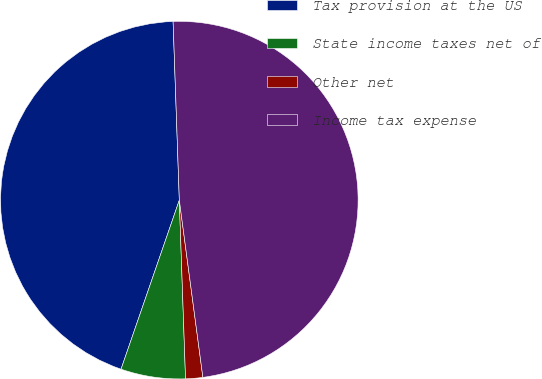<chart> <loc_0><loc_0><loc_500><loc_500><pie_chart><fcel>Tax provision at the US<fcel>State income taxes net of<fcel>Other net<fcel>Income tax expense<nl><fcel>44.16%<fcel>5.84%<fcel>1.55%<fcel>48.45%<nl></chart> 